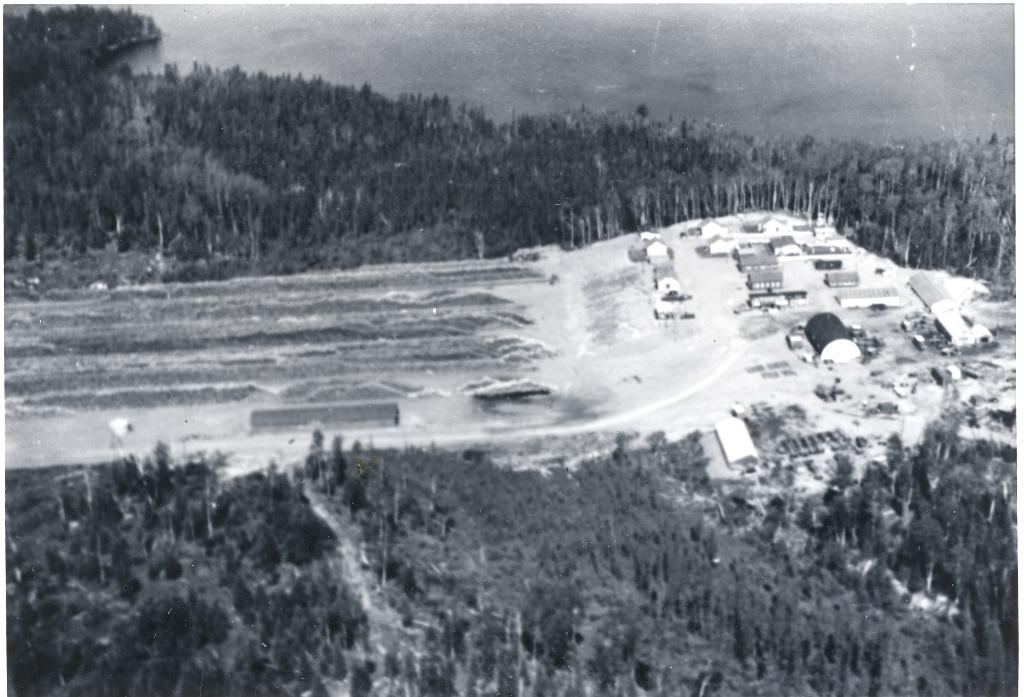What is the color scheme of the image? The image is black and white. Where are the trees located in the image? The trees are in the middle and bottom of the image. What structures can be seen on the right side of the image? There are houses on the right side of the image. What is visible at the top of the image? The sky is visible at the top of the image. How many ghosts are visible in the image? There are no ghosts present in the image. Can you tell me how many cows are grazing in the fields in the image? There are no fields or cows visible in the image. 